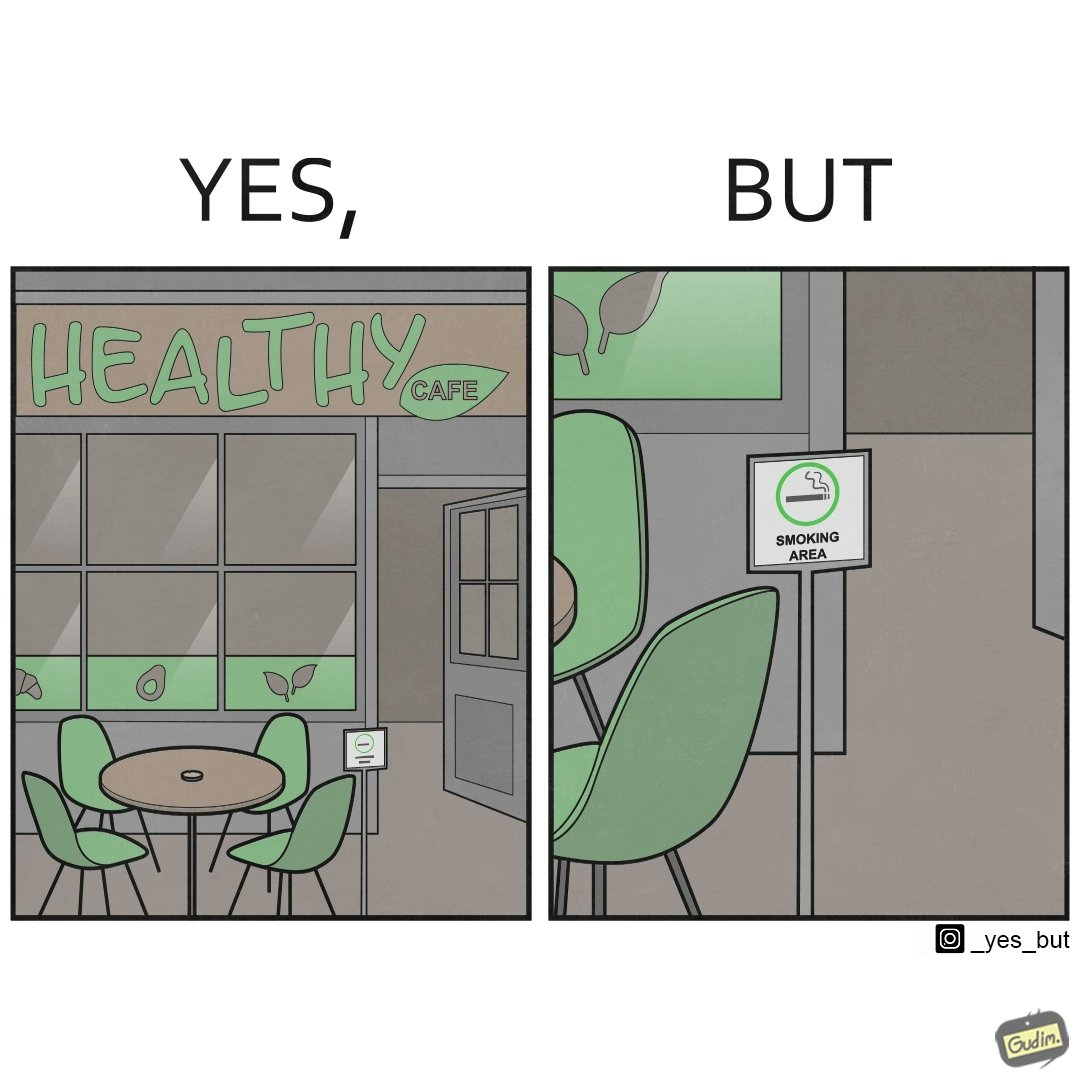Provide a description of this image. This image is funny because an eatery that calls itself the "healthy" cafe also has a smoking area, which is not very "healthy". If it really was a healthy cafe, it would not have a smoking area as smoking is injurious to health. Satire on the behavior of humans - both those that operate this cafe who made the decision of allowing smoking and creating a designated smoking area, and those that visit this healthy cafe to become "healthy", but then also indulge in very unhealthy habits simultaneously. 